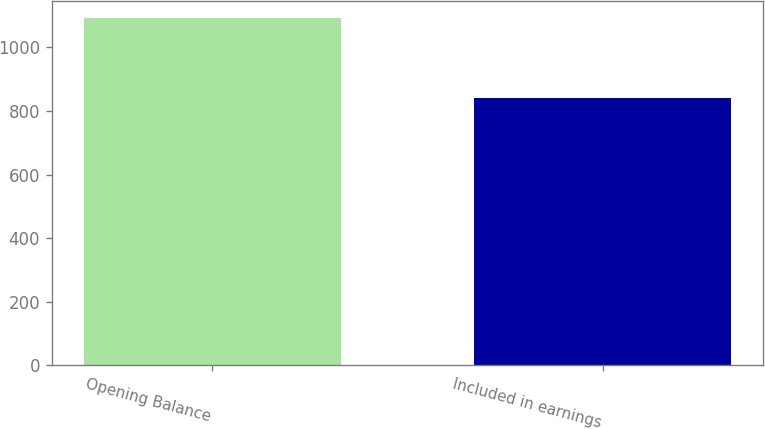<chart> <loc_0><loc_0><loc_500><loc_500><bar_chart><fcel>Opening Balance<fcel>Included in earnings<nl><fcel>1092<fcel>842<nl></chart> 